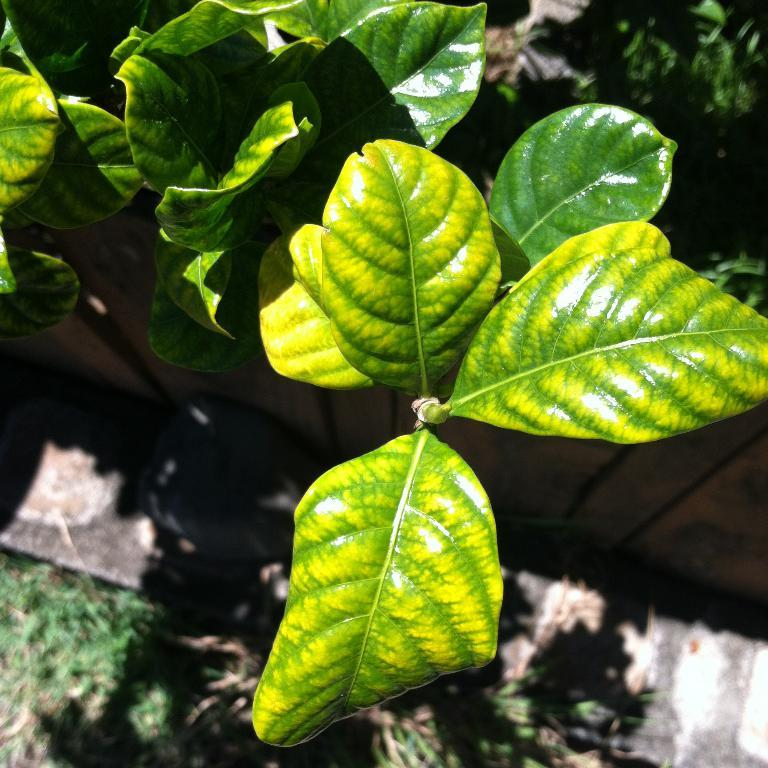What type of vegetation is present in the image? There are green leaves in the image. Can you describe the background of the image? The background of the image is blurry. What type of instrument is being played in the background of the image? There is no instrument present in the image, as the background is blurry and no musical instruments are mentioned in the facts. 